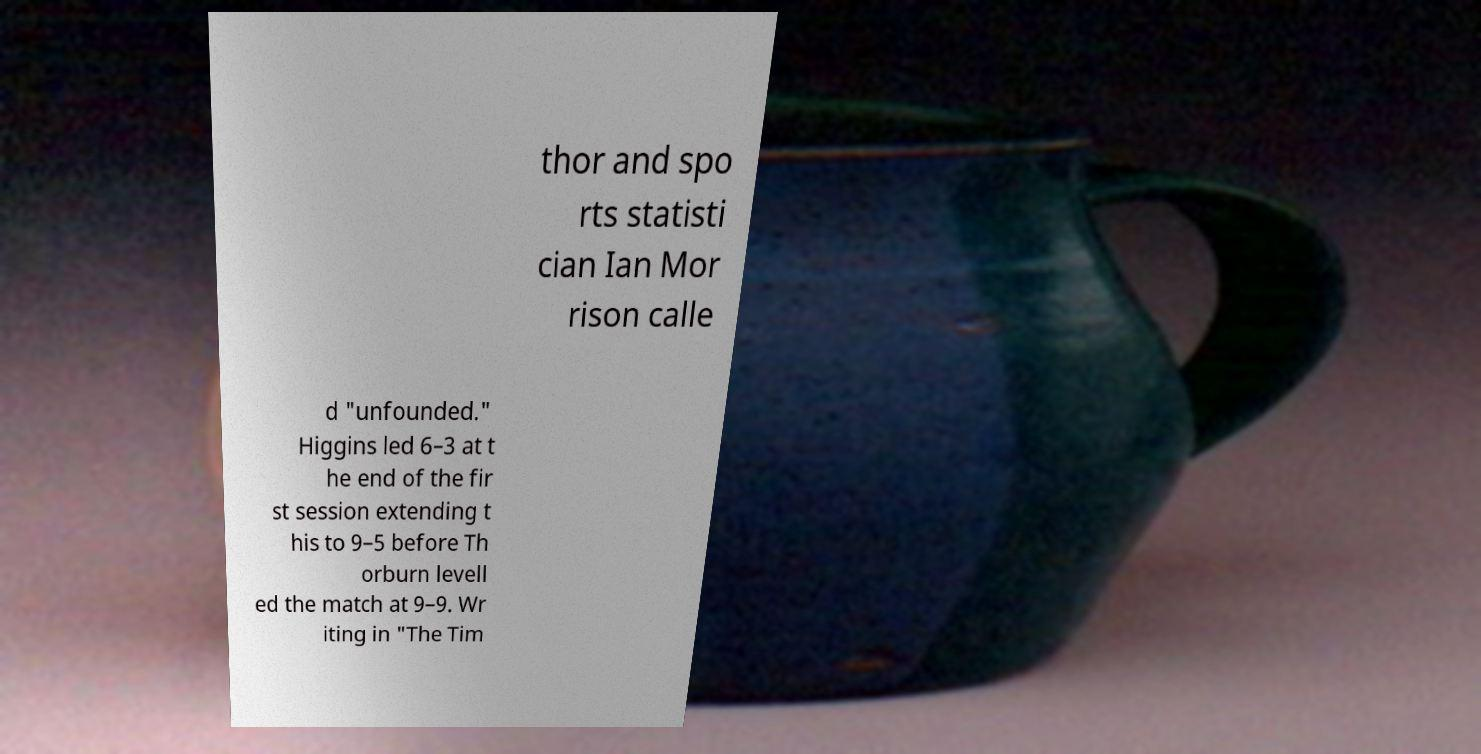Could you extract and type out the text from this image? thor and spo rts statisti cian Ian Mor rison calle d "unfounded." Higgins led 6–3 at t he end of the fir st session extending t his to 9–5 before Th orburn levell ed the match at 9–9. Wr iting in "The Tim 